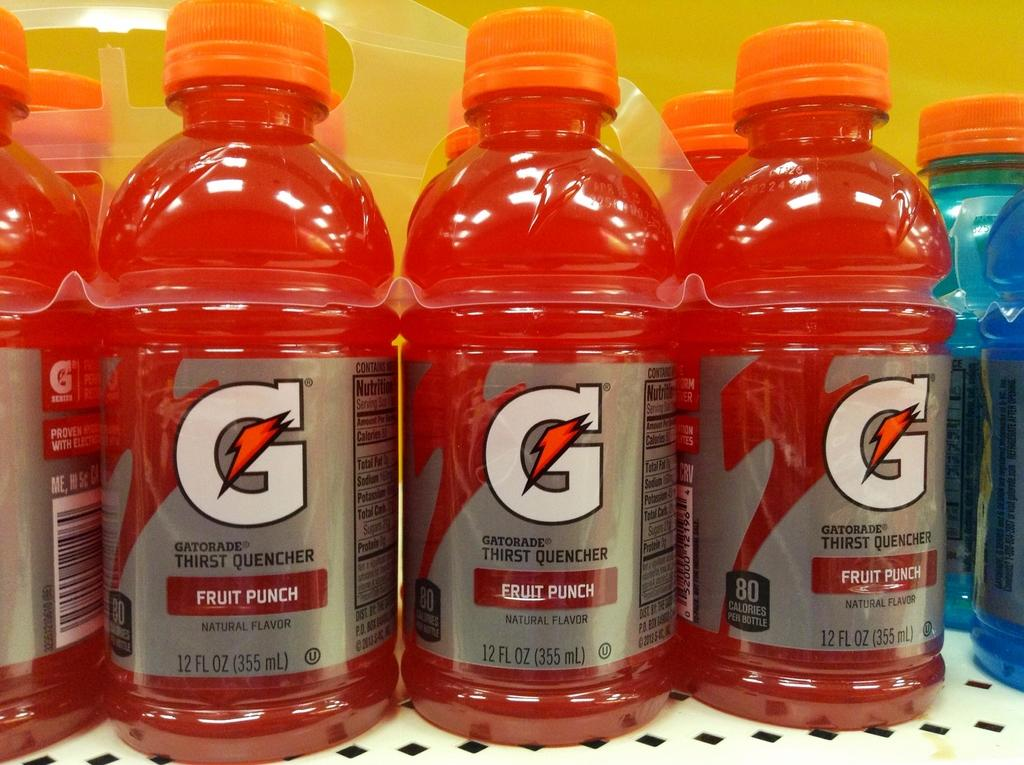<image>
Provide a brief description of the given image. a row of red fruit punch gatorade bottles next to blue gatorade bottles 